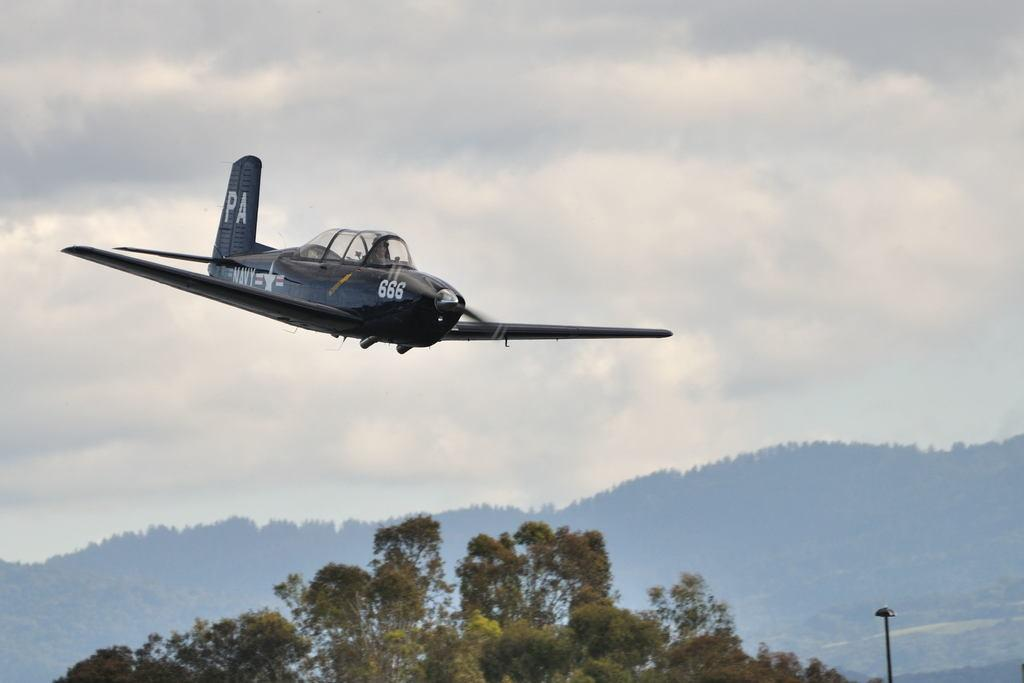<image>
Render a clear and concise summary of the photo. PA plane 666 flying on a cloudy day. 